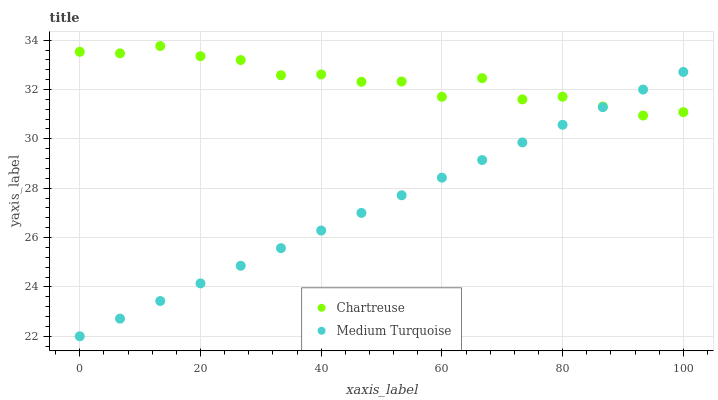Does Medium Turquoise have the minimum area under the curve?
Answer yes or no. Yes. Does Chartreuse have the maximum area under the curve?
Answer yes or no. Yes. Does Medium Turquoise have the maximum area under the curve?
Answer yes or no. No. Is Medium Turquoise the smoothest?
Answer yes or no. Yes. Is Chartreuse the roughest?
Answer yes or no. Yes. Is Medium Turquoise the roughest?
Answer yes or no. No. Does Medium Turquoise have the lowest value?
Answer yes or no. Yes. Does Chartreuse have the highest value?
Answer yes or no. Yes. Does Medium Turquoise have the highest value?
Answer yes or no. No. Does Medium Turquoise intersect Chartreuse?
Answer yes or no. Yes. Is Medium Turquoise less than Chartreuse?
Answer yes or no. No. Is Medium Turquoise greater than Chartreuse?
Answer yes or no. No. 